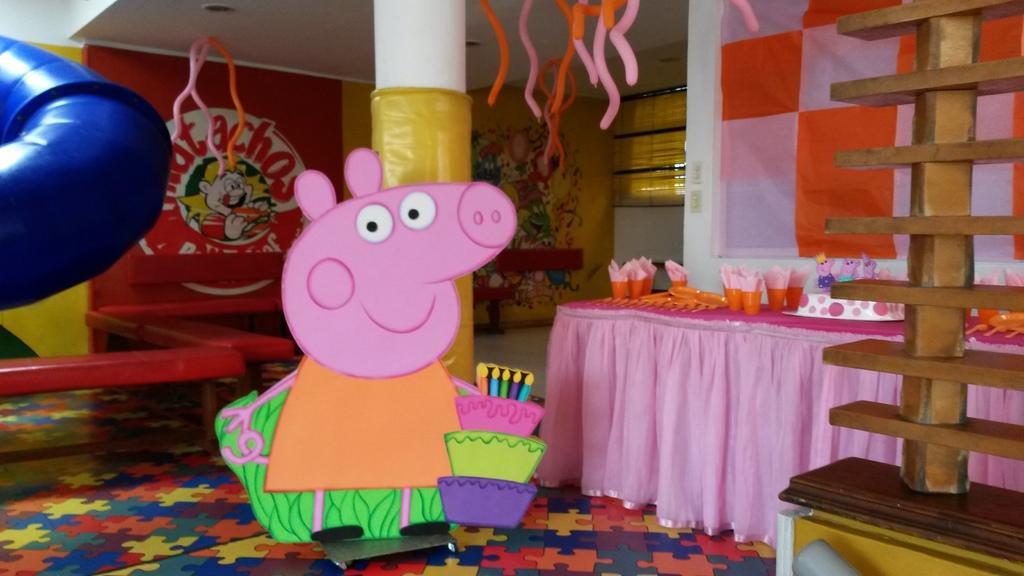Could you give a brief overview of what you see in this image? In this picture we can see cartoon image on the floor, wooden object on the platform, banner, glasses, cake and objects on the table, benches and objects. In the background of the image we can see painting on the wall and window. On the left side of the image we can see blue object. 